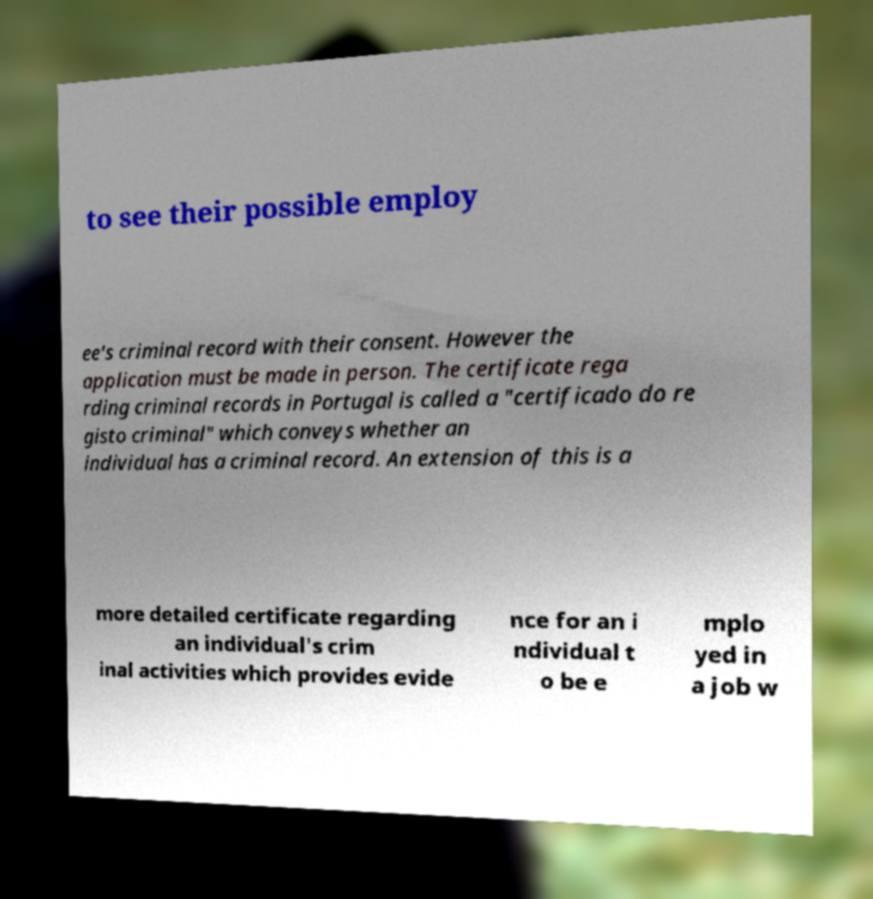Can you read and provide the text displayed in the image?This photo seems to have some interesting text. Can you extract and type it out for me? to see their possible employ ee's criminal record with their consent. However the application must be made in person. The certificate rega rding criminal records in Portugal is called a "certificado do re gisto criminal" which conveys whether an individual has a criminal record. An extension of this is a more detailed certificate regarding an individual's crim inal activities which provides evide nce for an i ndividual t o be e mplo yed in a job w 